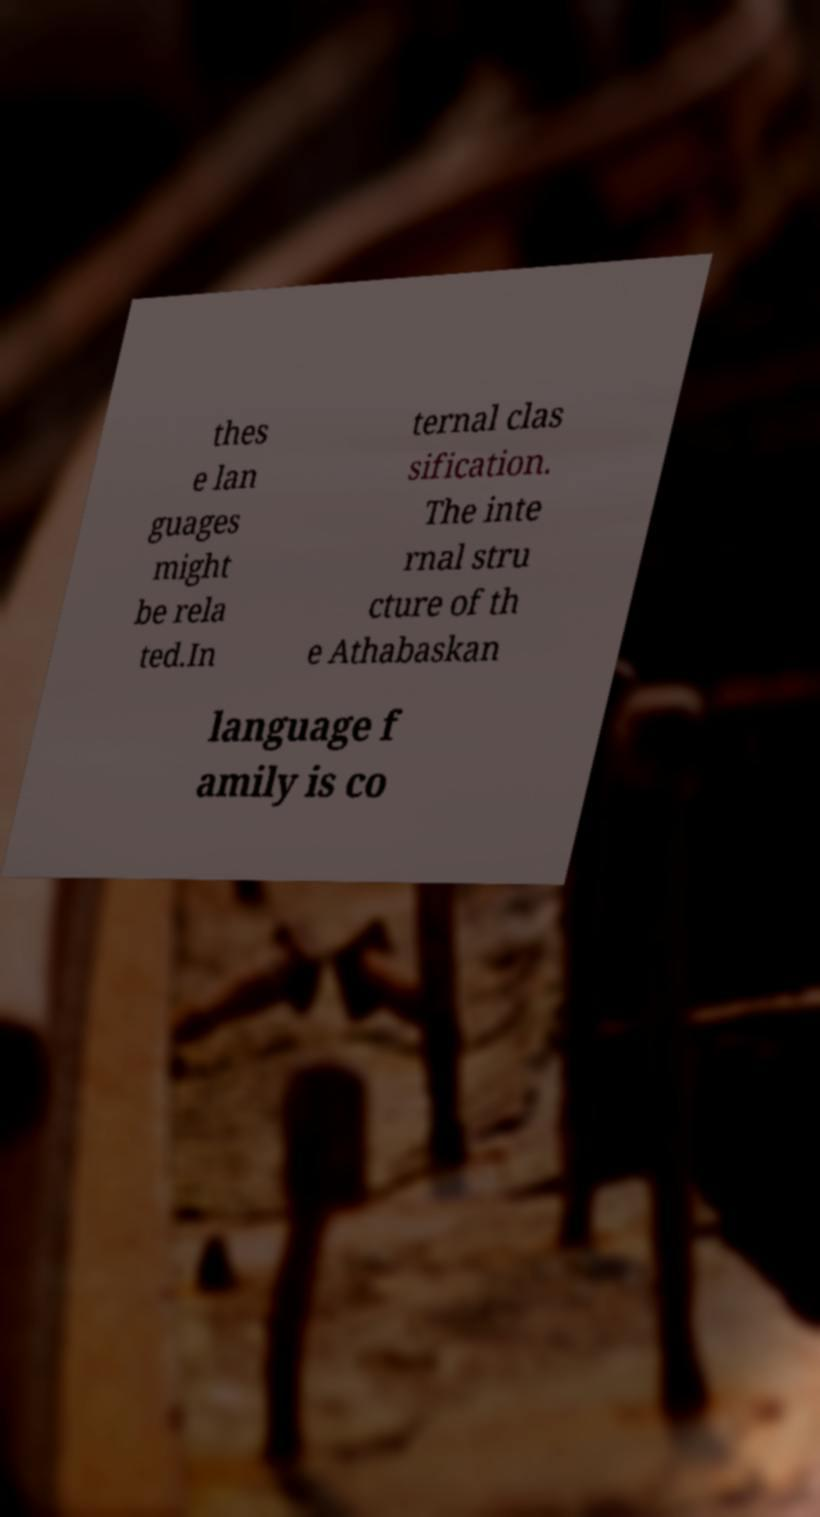Could you extract and type out the text from this image? thes e lan guages might be rela ted.In ternal clas sification. The inte rnal stru cture of th e Athabaskan language f amily is co 